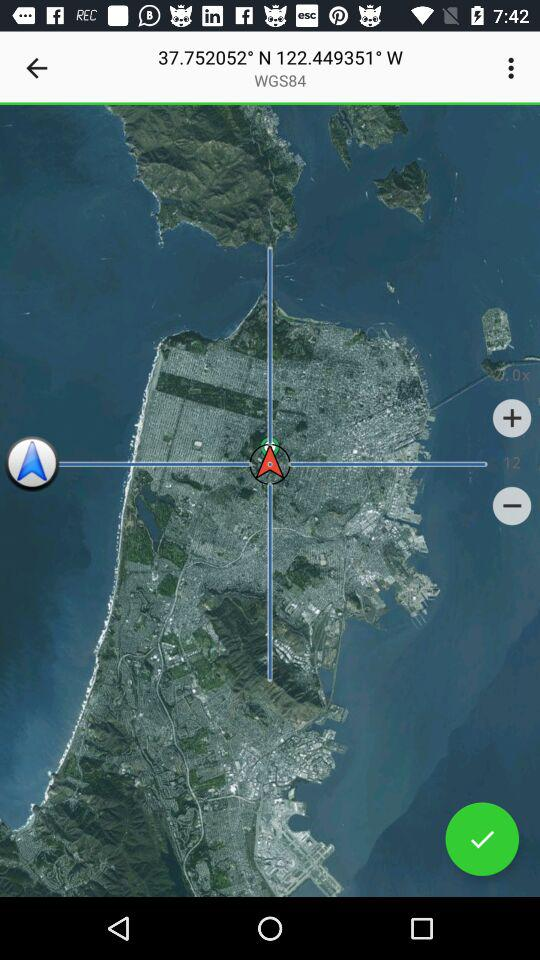How many degrees is it west? It is at 122.449351° west. 